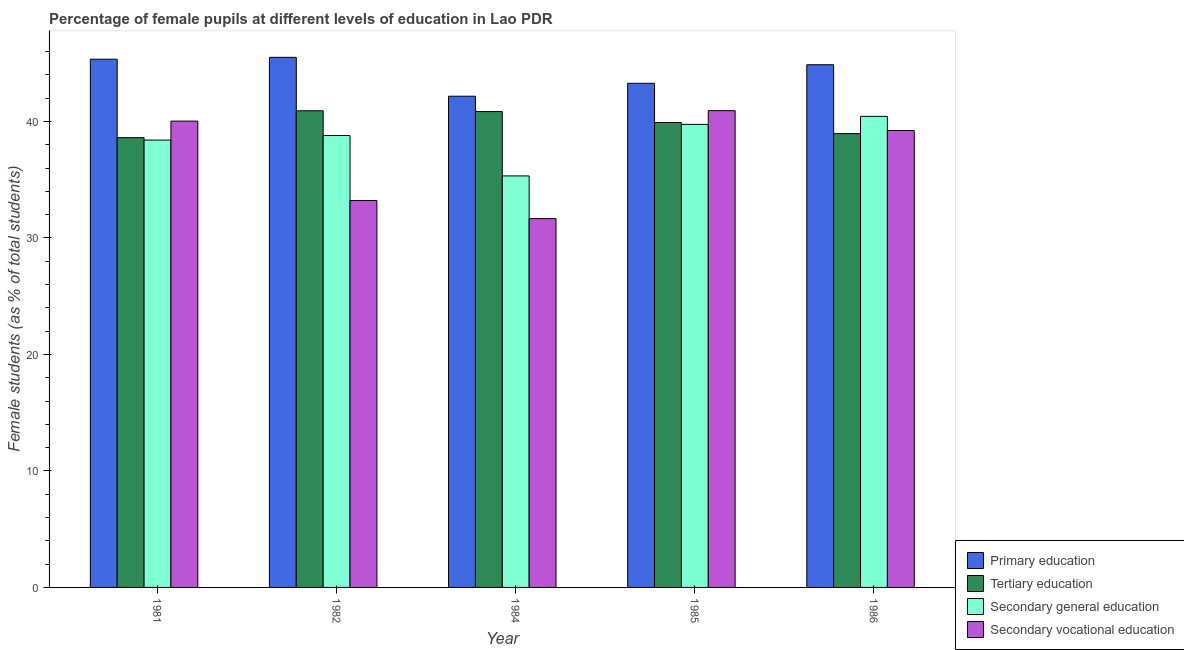How many different coloured bars are there?
Keep it short and to the point. 4. How many groups of bars are there?
Provide a short and direct response. 5. What is the label of the 4th group of bars from the left?
Your answer should be very brief. 1985. In how many cases, is the number of bars for a given year not equal to the number of legend labels?
Make the answer very short. 0. What is the percentage of female students in primary education in 1984?
Offer a very short reply. 42.16. Across all years, what is the maximum percentage of female students in primary education?
Keep it short and to the point. 45.5. Across all years, what is the minimum percentage of female students in tertiary education?
Ensure brevity in your answer.  38.61. What is the total percentage of female students in secondary vocational education in the graph?
Give a very brief answer. 185.03. What is the difference between the percentage of female students in secondary vocational education in 1984 and that in 1986?
Provide a succinct answer. -7.56. What is the difference between the percentage of female students in secondary vocational education in 1981 and the percentage of female students in secondary education in 1984?
Make the answer very short. 8.37. What is the average percentage of female students in secondary vocational education per year?
Your response must be concise. 37.01. In the year 1982, what is the difference between the percentage of female students in secondary vocational education and percentage of female students in primary education?
Your answer should be very brief. 0. What is the ratio of the percentage of female students in primary education in 1984 to that in 1986?
Provide a short and direct response. 0.94. Is the difference between the percentage of female students in tertiary education in 1982 and 1984 greater than the difference between the percentage of female students in primary education in 1982 and 1984?
Offer a very short reply. No. What is the difference between the highest and the second highest percentage of female students in secondary education?
Ensure brevity in your answer.  0.69. What is the difference between the highest and the lowest percentage of female students in secondary education?
Offer a very short reply. 5.11. In how many years, is the percentage of female students in secondary vocational education greater than the average percentage of female students in secondary vocational education taken over all years?
Give a very brief answer. 3. What does the 3rd bar from the left in 1984 represents?
Offer a terse response. Secondary general education. What does the 2nd bar from the right in 1984 represents?
Provide a succinct answer. Secondary general education. How many years are there in the graph?
Your answer should be very brief. 5. Where does the legend appear in the graph?
Your response must be concise. Bottom right. How many legend labels are there?
Offer a terse response. 4. What is the title of the graph?
Make the answer very short. Percentage of female pupils at different levels of education in Lao PDR. Does "Bird species" appear as one of the legend labels in the graph?
Your response must be concise. No. What is the label or title of the X-axis?
Your answer should be compact. Year. What is the label or title of the Y-axis?
Your answer should be compact. Female students (as % of total students). What is the Female students (as % of total students) in Primary education in 1981?
Keep it short and to the point. 45.34. What is the Female students (as % of total students) in Tertiary education in 1981?
Offer a terse response. 38.61. What is the Female students (as % of total students) in Secondary general education in 1981?
Offer a very short reply. 38.4. What is the Female students (as % of total students) in Secondary vocational education in 1981?
Provide a short and direct response. 40.03. What is the Female students (as % of total students) in Primary education in 1982?
Your response must be concise. 45.5. What is the Female students (as % of total students) in Tertiary education in 1982?
Offer a terse response. 40.91. What is the Female students (as % of total students) of Secondary general education in 1982?
Your response must be concise. 38.79. What is the Female students (as % of total students) of Secondary vocational education in 1982?
Your response must be concise. 33.21. What is the Female students (as % of total students) in Primary education in 1984?
Your answer should be very brief. 42.16. What is the Female students (as % of total students) in Tertiary education in 1984?
Provide a short and direct response. 40.84. What is the Female students (as % of total students) in Secondary general education in 1984?
Offer a very short reply. 35.32. What is the Female students (as % of total students) in Secondary vocational education in 1984?
Make the answer very short. 31.66. What is the Female students (as % of total students) in Primary education in 1985?
Ensure brevity in your answer.  43.27. What is the Female students (as % of total students) of Tertiary education in 1985?
Make the answer very short. 39.9. What is the Female students (as % of total students) of Secondary general education in 1985?
Your answer should be compact. 39.74. What is the Female students (as % of total students) of Secondary vocational education in 1985?
Make the answer very short. 40.92. What is the Female students (as % of total students) of Primary education in 1986?
Give a very brief answer. 44.86. What is the Female students (as % of total students) of Tertiary education in 1986?
Provide a succinct answer. 38.95. What is the Female students (as % of total students) in Secondary general education in 1986?
Provide a succinct answer. 40.43. What is the Female students (as % of total students) of Secondary vocational education in 1986?
Ensure brevity in your answer.  39.22. Across all years, what is the maximum Female students (as % of total students) in Primary education?
Ensure brevity in your answer.  45.5. Across all years, what is the maximum Female students (as % of total students) of Tertiary education?
Your response must be concise. 40.91. Across all years, what is the maximum Female students (as % of total students) of Secondary general education?
Provide a succinct answer. 40.43. Across all years, what is the maximum Female students (as % of total students) in Secondary vocational education?
Keep it short and to the point. 40.92. Across all years, what is the minimum Female students (as % of total students) in Primary education?
Your answer should be very brief. 42.16. Across all years, what is the minimum Female students (as % of total students) in Tertiary education?
Give a very brief answer. 38.61. Across all years, what is the minimum Female students (as % of total students) in Secondary general education?
Give a very brief answer. 35.32. Across all years, what is the minimum Female students (as % of total students) of Secondary vocational education?
Provide a succinct answer. 31.66. What is the total Female students (as % of total students) in Primary education in the graph?
Provide a succinct answer. 221.13. What is the total Female students (as % of total students) of Tertiary education in the graph?
Your answer should be compact. 199.22. What is the total Female students (as % of total students) in Secondary general education in the graph?
Offer a very short reply. 192.69. What is the total Female students (as % of total students) in Secondary vocational education in the graph?
Your response must be concise. 185.03. What is the difference between the Female students (as % of total students) in Primary education in 1981 and that in 1982?
Your answer should be compact. -0.16. What is the difference between the Female students (as % of total students) in Tertiary education in 1981 and that in 1982?
Make the answer very short. -2.31. What is the difference between the Female students (as % of total students) of Secondary general education in 1981 and that in 1982?
Provide a succinct answer. -0.39. What is the difference between the Female students (as % of total students) of Secondary vocational education in 1981 and that in 1982?
Offer a very short reply. 6.82. What is the difference between the Female students (as % of total students) in Primary education in 1981 and that in 1984?
Your answer should be compact. 3.17. What is the difference between the Female students (as % of total students) in Tertiary education in 1981 and that in 1984?
Provide a short and direct response. -2.24. What is the difference between the Female students (as % of total students) in Secondary general education in 1981 and that in 1984?
Keep it short and to the point. 3.08. What is the difference between the Female students (as % of total students) of Secondary vocational education in 1981 and that in 1984?
Make the answer very short. 8.37. What is the difference between the Female students (as % of total students) of Primary education in 1981 and that in 1985?
Your answer should be very brief. 2.07. What is the difference between the Female students (as % of total students) in Tertiary education in 1981 and that in 1985?
Offer a very short reply. -1.3. What is the difference between the Female students (as % of total students) of Secondary general education in 1981 and that in 1985?
Give a very brief answer. -1.34. What is the difference between the Female students (as % of total students) of Secondary vocational education in 1981 and that in 1985?
Offer a terse response. -0.9. What is the difference between the Female students (as % of total students) of Primary education in 1981 and that in 1986?
Ensure brevity in your answer.  0.47. What is the difference between the Female students (as % of total students) in Tertiary education in 1981 and that in 1986?
Offer a very short reply. -0.35. What is the difference between the Female students (as % of total students) in Secondary general education in 1981 and that in 1986?
Offer a terse response. -2.04. What is the difference between the Female students (as % of total students) in Secondary vocational education in 1981 and that in 1986?
Provide a succinct answer. 0.81. What is the difference between the Female students (as % of total students) of Primary education in 1982 and that in 1984?
Your answer should be compact. 3.34. What is the difference between the Female students (as % of total students) in Tertiary education in 1982 and that in 1984?
Keep it short and to the point. 0.07. What is the difference between the Female students (as % of total students) of Secondary general education in 1982 and that in 1984?
Offer a terse response. 3.47. What is the difference between the Female students (as % of total students) of Secondary vocational education in 1982 and that in 1984?
Make the answer very short. 1.55. What is the difference between the Female students (as % of total students) of Primary education in 1982 and that in 1985?
Provide a succinct answer. 2.23. What is the difference between the Female students (as % of total students) of Tertiary education in 1982 and that in 1985?
Offer a terse response. 1.01. What is the difference between the Female students (as % of total students) in Secondary general education in 1982 and that in 1985?
Your response must be concise. -0.96. What is the difference between the Female students (as % of total students) in Secondary vocational education in 1982 and that in 1985?
Offer a terse response. -7.72. What is the difference between the Female students (as % of total students) of Primary education in 1982 and that in 1986?
Your response must be concise. 0.64. What is the difference between the Female students (as % of total students) in Tertiary education in 1982 and that in 1986?
Your answer should be compact. 1.96. What is the difference between the Female students (as % of total students) in Secondary general education in 1982 and that in 1986?
Give a very brief answer. -1.65. What is the difference between the Female students (as % of total students) in Secondary vocational education in 1982 and that in 1986?
Ensure brevity in your answer.  -6.01. What is the difference between the Female students (as % of total students) of Primary education in 1984 and that in 1985?
Provide a succinct answer. -1.11. What is the difference between the Female students (as % of total students) in Tertiary education in 1984 and that in 1985?
Offer a terse response. 0.94. What is the difference between the Female students (as % of total students) of Secondary general education in 1984 and that in 1985?
Give a very brief answer. -4.42. What is the difference between the Female students (as % of total students) of Secondary vocational education in 1984 and that in 1985?
Your answer should be very brief. -9.27. What is the difference between the Female students (as % of total students) of Primary education in 1984 and that in 1986?
Provide a short and direct response. -2.7. What is the difference between the Female students (as % of total students) in Tertiary education in 1984 and that in 1986?
Your response must be concise. 1.89. What is the difference between the Female students (as % of total students) in Secondary general education in 1984 and that in 1986?
Offer a terse response. -5.11. What is the difference between the Female students (as % of total students) of Secondary vocational education in 1984 and that in 1986?
Offer a terse response. -7.56. What is the difference between the Female students (as % of total students) in Primary education in 1985 and that in 1986?
Keep it short and to the point. -1.59. What is the difference between the Female students (as % of total students) in Tertiary education in 1985 and that in 1986?
Provide a succinct answer. 0.95. What is the difference between the Female students (as % of total students) in Secondary general education in 1985 and that in 1986?
Your answer should be compact. -0.69. What is the difference between the Female students (as % of total students) of Secondary vocational education in 1985 and that in 1986?
Offer a very short reply. 1.71. What is the difference between the Female students (as % of total students) in Primary education in 1981 and the Female students (as % of total students) in Tertiary education in 1982?
Your response must be concise. 4.42. What is the difference between the Female students (as % of total students) of Primary education in 1981 and the Female students (as % of total students) of Secondary general education in 1982?
Ensure brevity in your answer.  6.55. What is the difference between the Female students (as % of total students) of Primary education in 1981 and the Female students (as % of total students) of Secondary vocational education in 1982?
Provide a succinct answer. 12.13. What is the difference between the Female students (as % of total students) in Tertiary education in 1981 and the Female students (as % of total students) in Secondary general education in 1982?
Offer a very short reply. -0.18. What is the difference between the Female students (as % of total students) of Tertiary education in 1981 and the Female students (as % of total students) of Secondary vocational education in 1982?
Provide a succinct answer. 5.4. What is the difference between the Female students (as % of total students) of Secondary general education in 1981 and the Female students (as % of total students) of Secondary vocational education in 1982?
Offer a terse response. 5.19. What is the difference between the Female students (as % of total students) in Primary education in 1981 and the Female students (as % of total students) in Tertiary education in 1984?
Your answer should be compact. 4.49. What is the difference between the Female students (as % of total students) of Primary education in 1981 and the Female students (as % of total students) of Secondary general education in 1984?
Your answer should be very brief. 10.02. What is the difference between the Female students (as % of total students) in Primary education in 1981 and the Female students (as % of total students) in Secondary vocational education in 1984?
Keep it short and to the point. 13.68. What is the difference between the Female students (as % of total students) of Tertiary education in 1981 and the Female students (as % of total students) of Secondary general education in 1984?
Make the answer very short. 3.28. What is the difference between the Female students (as % of total students) in Tertiary education in 1981 and the Female students (as % of total students) in Secondary vocational education in 1984?
Give a very brief answer. 6.95. What is the difference between the Female students (as % of total students) of Secondary general education in 1981 and the Female students (as % of total students) of Secondary vocational education in 1984?
Your response must be concise. 6.74. What is the difference between the Female students (as % of total students) of Primary education in 1981 and the Female students (as % of total students) of Tertiary education in 1985?
Provide a short and direct response. 5.43. What is the difference between the Female students (as % of total students) in Primary education in 1981 and the Female students (as % of total students) in Secondary general education in 1985?
Give a very brief answer. 5.59. What is the difference between the Female students (as % of total students) in Primary education in 1981 and the Female students (as % of total students) in Secondary vocational education in 1985?
Provide a short and direct response. 4.41. What is the difference between the Female students (as % of total students) in Tertiary education in 1981 and the Female students (as % of total students) in Secondary general education in 1985?
Offer a terse response. -1.14. What is the difference between the Female students (as % of total students) of Tertiary education in 1981 and the Female students (as % of total students) of Secondary vocational education in 1985?
Keep it short and to the point. -2.32. What is the difference between the Female students (as % of total students) in Secondary general education in 1981 and the Female students (as % of total students) in Secondary vocational education in 1985?
Offer a terse response. -2.52. What is the difference between the Female students (as % of total students) of Primary education in 1981 and the Female students (as % of total students) of Tertiary education in 1986?
Provide a short and direct response. 6.38. What is the difference between the Female students (as % of total students) of Primary education in 1981 and the Female students (as % of total students) of Secondary general education in 1986?
Give a very brief answer. 4.9. What is the difference between the Female students (as % of total students) of Primary education in 1981 and the Female students (as % of total students) of Secondary vocational education in 1986?
Offer a terse response. 6.12. What is the difference between the Female students (as % of total students) of Tertiary education in 1981 and the Female students (as % of total students) of Secondary general education in 1986?
Ensure brevity in your answer.  -1.83. What is the difference between the Female students (as % of total students) of Tertiary education in 1981 and the Female students (as % of total students) of Secondary vocational education in 1986?
Make the answer very short. -0.61. What is the difference between the Female students (as % of total students) in Secondary general education in 1981 and the Female students (as % of total students) in Secondary vocational education in 1986?
Make the answer very short. -0.82. What is the difference between the Female students (as % of total students) in Primary education in 1982 and the Female students (as % of total students) in Tertiary education in 1984?
Ensure brevity in your answer.  4.66. What is the difference between the Female students (as % of total students) of Primary education in 1982 and the Female students (as % of total students) of Secondary general education in 1984?
Offer a terse response. 10.18. What is the difference between the Female students (as % of total students) of Primary education in 1982 and the Female students (as % of total students) of Secondary vocational education in 1984?
Offer a terse response. 13.84. What is the difference between the Female students (as % of total students) of Tertiary education in 1982 and the Female students (as % of total students) of Secondary general education in 1984?
Offer a very short reply. 5.59. What is the difference between the Female students (as % of total students) in Tertiary education in 1982 and the Female students (as % of total students) in Secondary vocational education in 1984?
Your answer should be very brief. 9.26. What is the difference between the Female students (as % of total students) of Secondary general education in 1982 and the Female students (as % of total students) of Secondary vocational education in 1984?
Your answer should be compact. 7.13. What is the difference between the Female students (as % of total students) in Primary education in 1982 and the Female students (as % of total students) in Tertiary education in 1985?
Your answer should be very brief. 5.6. What is the difference between the Female students (as % of total students) of Primary education in 1982 and the Female students (as % of total students) of Secondary general education in 1985?
Provide a succinct answer. 5.76. What is the difference between the Female students (as % of total students) of Primary education in 1982 and the Female students (as % of total students) of Secondary vocational education in 1985?
Offer a terse response. 4.58. What is the difference between the Female students (as % of total students) of Tertiary education in 1982 and the Female students (as % of total students) of Secondary general education in 1985?
Provide a short and direct response. 1.17. What is the difference between the Female students (as % of total students) of Tertiary education in 1982 and the Female students (as % of total students) of Secondary vocational education in 1985?
Keep it short and to the point. -0.01. What is the difference between the Female students (as % of total students) of Secondary general education in 1982 and the Female students (as % of total students) of Secondary vocational education in 1985?
Offer a terse response. -2.14. What is the difference between the Female students (as % of total students) of Primary education in 1982 and the Female students (as % of total students) of Tertiary education in 1986?
Give a very brief answer. 6.55. What is the difference between the Female students (as % of total students) of Primary education in 1982 and the Female students (as % of total students) of Secondary general education in 1986?
Make the answer very short. 5.07. What is the difference between the Female students (as % of total students) in Primary education in 1982 and the Female students (as % of total students) in Secondary vocational education in 1986?
Offer a very short reply. 6.28. What is the difference between the Female students (as % of total students) of Tertiary education in 1982 and the Female students (as % of total students) of Secondary general education in 1986?
Offer a very short reply. 0.48. What is the difference between the Female students (as % of total students) in Tertiary education in 1982 and the Female students (as % of total students) in Secondary vocational education in 1986?
Your answer should be compact. 1.7. What is the difference between the Female students (as % of total students) of Secondary general education in 1982 and the Female students (as % of total students) of Secondary vocational education in 1986?
Your answer should be very brief. -0.43. What is the difference between the Female students (as % of total students) in Primary education in 1984 and the Female students (as % of total students) in Tertiary education in 1985?
Offer a terse response. 2.26. What is the difference between the Female students (as % of total students) of Primary education in 1984 and the Female students (as % of total students) of Secondary general education in 1985?
Make the answer very short. 2.42. What is the difference between the Female students (as % of total students) of Primary education in 1984 and the Female students (as % of total students) of Secondary vocational education in 1985?
Give a very brief answer. 1.24. What is the difference between the Female students (as % of total students) in Tertiary education in 1984 and the Female students (as % of total students) in Secondary general education in 1985?
Your answer should be compact. 1.1. What is the difference between the Female students (as % of total students) of Tertiary education in 1984 and the Female students (as % of total students) of Secondary vocational education in 1985?
Offer a very short reply. -0.08. What is the difference between the Female students (as % of total students) in Secondary general education in 1984 and the Female students (as % of total students) in Secondary vocational education in 1985?
Your answer should be compact. -5.6. What is the difference between the Female students (as % of total students) of Primary education in 1984 and the Female students (as % of total students) of Tertiary education in 1986?
Provide a short and direct response. 3.21. What is the difference between the Female students (as % of total students) of Primary education in 1984 and the Female students (as % of total students) of Secondary general education in 1986?
Provide a short and direct response. 1.73. What is the difference between the Female students (as % of total students) of Primary education in 1984 and the Female students (as % of total students) of Secondary vocational education in 1986?
Give a very brief answer. 2.95. What is the difference between the Female students (as % of total students) of Tertiary education in 1984 and the Female students (as % of total students) of Secondary general education in 1986?
Ensure brevity in your answer.  0.41. What is the difference between the Female students (as % of total students) in Tertiary education in 1984 and the Female students (as % of total students) in Secondary vocational education in 1986?
Your response must be concise. 1.63. What is the difference between the Female students (as % of total students) in Secondary general education in 1984 and the Female students (as % of total students) in Secondary vocational education in 1986?
Provide a short and direct response. -3.9. What is the difference between the Female students (as % of total students) in Primary education in 1985 and the Female students (as % of total students) in Tertiary education in 1986?
Your answer should be very brief. 4.32. What is the difference between the Female students (as % of total students) of Primary education in 1985 and the Female students (as % of total students) of Secondary general education in 1986?
Provide a succinct answer. 2.84. What is the difference between the Female students (as % of total students) in Primary education in 1985 and the Female students (as % of total students) in Secondary vocational education in 1986?
Offer a very short reply. 4.05. What is the difference between the Female students (as % of total students) in Tertiary education in 1985 and the Female students (as % of total students) in Secondary general education in 1986?
Your response must be concise. -0.53. What is the difference between the Female students (as % of total students) of Tertiary education in 1985 and the Female students (as % of total students) of Secondary vocational education in 1986?
Your answer should be compact. 0.69. What is the difference between the Female students (as % of total students) in Secondary general education in 1985 and the Female students (as % of total students) in Secondary vocational education in 1986?
Provide a short and direct response. 0.53. What is the average Female students (as % of total students) in Primary education per year?
Offer a very short reply. 44.23. What is the average Female students (as % of total students) in Tertiary education per year?
Provide a succinct answer. 39.84. What is the average Female students (as % of total students) of Secondary general education per year?
Ensure brevity in your answer.  38.54. What is the average Female students (as % of total students) in Secondary vocational education per year?
Ensure brevity in your answer.  37.01. In the year 1981, what is the difference between the Female students (as % of total students) of Primary education and Female students (as % of total students) of Tertiary education?
Provide a succinct answer. 6.73. In the year 1981, what is the difference between the Female students (as % of total students) of Primary education and Female students (as % of total students) of Secondary general education?
Your answer should be compact. 6.94. In the year 1981, what is the difference between the Female students (as % of total students) of Primary education and Female students (as % of total students) of Secondary vocational education?
Provide a short and direct response. 5.31. In the year 1981, what is the difference between the Female students (as % of total students) in Tertiary education and Female students (as % of total students) in Secondary general education?
Offer a terse response. 0.21. In the year 1981, what is the difference between the Female students (as % of total students) in Tertiary education and Female students (as % of total students) in Secondary vocational education?
Make the answer very short. -1.42. In the year 1981, what is the difference between the Female students (as % of total students) of Secondary general education and Female students (as % of total students) of Secondary vocational education?
Provide a succinct answer. -1.63. In the year 1982, what is the difference between the Female students (as % of total students) in Primary education and Female students (as % of total students) in Tertiary education?
Keep it short and to the point. 4.59. In the year 1982, what is the difference between the Female students (as % of total students) of Primary education and Female students (as % of total students) of Secondary general education?
Your answer should be very brief. 6.71. In the year 1982, what is the difference between the Female students (as % of total students) of Primary education and Female students (as % of total students) of Secondary vocational education?
Offer a terse response. 12.29. In the year 1982, what is the difference between the Female students (as % of total students) in Tertiary education and Female students (as % of total students) in Secondary general education?
Ensure brevity in your answer.  2.13. In the year 1982, what is the difference between the Female students (as % of total students) in Tertiary education and Female students (as % of total students) in Secondary vocational education?
Your answer should be very brief. 7.71. In the year 1982, what is the difference between the Female students (as % of total students) in Secondary general education and Female students (as % of total students) in Secondary vocational education?
Make the answer very short. 5.58. In the year 1984, what is the difference between the Female students (as % of total students) in Primary education and Female students (as % of total students) in Tertiary education?
Your answer should be compact. 1.32. In the year 1984, what is the difference between the Female students (as % of total students) in Primary education and Female students (as % of total students) in Secondary general education?
Provide a short and direct response. 6.84. In the year 1984, what is the difference between the Female students (as % of total students) of Primary education and Female students (as % of total students) of Secondary vocational education?
Keep it short and to the point. 10.5. In the year 1984, what is the difference between the Female students (as % of total students) in Tertiary education and Female students (as % of total students) in Secondary general education?
Offer a very short reply. 5.52. In the year 1984, what is the difference between the Female students (as % of total students) of Tertiary education and Female students (as % of total students) of Secondary vocational education?
Provide a succinct answer. 9.19. In the year 1984, what is the difference between the Female students (as % of total students) in Secondary general education and Female students (as % of total students) in Secondary vocational education?
Give a very brief answer. 3.66. In the year 1985, what is the difference between the Female students (as % of total students) in Primary education and Female students (as % of total students) in Tertiary education?
Your response must be concise. 3.37. In the year 1985, what is the difference between the Female students (as % of total students) of Primary education and Female students (as % of total students) of Secondary general education?
Offer a terse response. 3.53. In the year 1985, what is the difference between the Female students (as % of total students) in Primary education and Female students (as % of total students) in Secondary vocational education?
Your answer should be very brief. 2.35. In the year 1985, what is the difference between the Female students (as % of total students) in Tertiary education and Female students (as % of total students) in Secondary general education?
Offer a very short reply. 0.16. In the year 1985, what is the difference between the Female students (as % of total students) in Tertiary education and Female students (as % of total students) in Secondary vocational education?
Your answer should be very brief. -1.02. In the year 1985, what is the difference between the Female students (as % of total students) in Secondary general education and Female students (as % of total students) in Secondary vocational education?
Ensure brevity in your answer.  -1.18. In the year 1986, what is the difference between the Female students (as % of total students) of Primary education and Female students (as % of total students) of Tertiary education?
Make the answer very short. 5.91. In the year 1986, what is the difference between the Female students (as % of total students) of Primary education and Female students (as % of total students) of Secondary general education?
Your answer should be compact. 4.43. In the year 1986, what is the difference between the Female students (as % of total students) in Primary education and Female students (as % of total students) in Secondary vocational education?
Provide a short and direct response. 5.65. In the year 1986, what is the difference between the Female students (as % of total students) in Tertiary education and Female students (as % of total students) in Secondary general education?
Ensure brevity in your answer.  -1.48. In the year 1986, what is the difference between the Female students (as % of total students) of Tertiary education and Female students (as % of total students) of Secondary vocational education?
Provide a short and direct response. -0.26. In the year 1986, what is the difference between the Female students (as % of total students) in Secondary general education and Female students (as % of total students) in Secondary vocational education?
Keep it short and to the point. 1.22. What is the ratio of the Female students (as % of total students) in Tertiary education in 1981 to that in 1982?
Make the answer very short. 0.94. What is the ratio of the Female students (as % of total students) of Secondary vocational education in 1981 to that in 1982?
Provide a short and direct response. 1.21. What is the ratio of the Female students (as % of total students) in Primary education in 1981 to that in 1984?
Your answer should be very brief. 1.08. What is the ratio of the Female students (as % of total students) of Tertiary education in 1981 to that in 1984?
Make the answer very short. 0.95. What is the ratio of the Female students (as % of total students) of Secondary general education in 1981 to that in 1984?
Give a very brief answer. 1.09. What is the ratio of the Female students (as % of total students) of Secondary vocational education in 1981 to that in 1984?
Offer a terse response. 1.26. What is the ratio of the Female students (as % of total students) in Primary education in 1981 to that in 1985?
Offer a very short reply. 1.05. What is the ratio of the Female students (as % of total students) of Tertiary education in 1981 to that in 1985?
Keep it short and to the point. 0.97. What is the ratio of the Female students (as % of total students) of Secondary general education in 1981 to that in 1985?
Provide a short and direct response. 0.97. What is the ratio of the Female students (as % of total students) in Secondary vocational education in 1981 to that in 1985?
Offer a terse response. 0.98. What is the ratio of the Female students (as % of total students) in Primary education in 1981 to that in 1986?
Provide a short and direct response. 1.01. What is the ratio of the Female students (as % of total students) of Tertiary education in 1981 to that in 1986?
Make the answer very short. 0.99. What is the ratio of the Female students (as % of total students) of Secondary general education in 1981 to that in 1986?
Give a very brief answer. 0.95. What is the ratio of the Female students (as % of total students) in Secondary vocational education in 1981 to that in 1986?
Your response must be concise. 1.02. What is the ratio of the Female students (as % of total students) in Primary education in 1982 to that in 1984?
Keep it short and to the point. 1.08. What is the ratio of the Female students (as % of total students) in Tertiary education in 1982 to that in 1984?
Your answer should be compact. 1. What is the ratio of the Female students (as % of total students) of Secondary general education in 1982 to that in 1984?
Make the answer very short. 1.1. What is the ratio of the Female students (as % of total students) in Secondary vocational education in 1982 to that in 1984?
Offer a very short reply. 1.05. What is the ratio of the Female students (as % of total students) in Primary education in 1982 to that in 1985?
Your answer should be very brief. 1.05. What is the ratio of the Female students (as % of total students) in Tertiary education in 1982 to that in 1985?
Offer a terse response. 1.03. What is the ratio of the Female students (as % of total students) of Secondary general education in 1982 to that in 1985?
Your response must be concise. 0.98. What is the ratio of the Female students (as % of total students) of Secondary vocational education in 1982 to that in 1985?
Keep it short and to the point. 0.81. What is the ratio of the Female students (as % of total students) in Primary education in 1982 to that in 1986?
Offer a terse response. 1.01. What is the ratio of the Female students (as % of total students) of Tertiary education in 1982 to that in 1986?
Your answer should be compact. 1.05. What is the ratio of the Female students (as % of total students) of Secondary general education in 1982 to that in 1986?
Keep it short and to the point. 0.96. What is the ratio of the Female students (as % of total students) in Secondary vocational education in 1982 to that in 1986?
Your response must be concise. 0.85. What is the ratio of the Female students (as % of total students) of Primary education in 1984 to that in 1985?
Offer a very short reply. 0.97. What is the ratio of the Female students (as % of total students) of Tertiary education in 1984 to that in 1985?
Ensure brevity in your answer.  1.02. What is the ratio of the Female students (as % of total students) of Secondary general education in 1984 to that in 1985?
Ensure brevity in your answer.  0.89. What is the ratio of the Female students (as % of total students) in Secondary vocational education in 1984 to that in 1985?
Provide a succinct answer. 0.77. What is the ratio of the Female students (as % of total students) of Primary education in 1984 to that in 1986?
Offer a terse response. 0.94. What is the ratio of the Female students (as % of total students) in Tertiary education in 1984 to that in 1986?
Make the answer very short. 1.05. What is the ratio of the Female students (as % of total students) in Secondary general education in 1984 to that in 1986?
Provide a short and direct response. 0.87. What is the ratio of the Female students (as % of total students) in Secondary vocational education in 1984 to that in 1986?
Your answer should be compact. 0.81. What is the ratio of the Female students (as % of total students) in Primary education in 1985 to that in 1986?
Your response must be concise. 0.96. What is the ratio of the Female students (as % of total students) of Tertiary education in 1985 to that in 1986?
Ensure brevity in your answer.  1.02. What is the ratio of the Female students (as % of total students) in Secondary general education in 1985 to that in 1986?
Give a very brief answer. 0.98. What is the ratio of the Female students (as % of total students) of Secondary vocational education in 1985 to that in 1986?
Keep it short and to the point. 1.04. What is the difference between the highest and the second highest Female students (as % of total students) of Primary education?
Give a very brief answer. 0.16. What is the difference between the highest and the second highest Female students (as % of total students) in Tertiary education?
Your response must be concise. 0.07. What is the difference between the highest and the second highest Female students (as % of total students) of Secondary general education?
Make the answer very short. 0.69. What is the difference between the highest and the second highest Female students (as % of total students) in Secondary vocational education?
Your answer should be very brief. 0.9. What is the difference between the highest and the lowest Female students (as % of total students) of Primary education?
Provide a short and direct response. 3.34. What is the difference between the highest and the lowest Female students (as % of total students) in Tertiary education?
Provide a succinct answer. 2.31. What is the difference between the highest and the lowest Female students (as % of total students) of Secondary general education?
Keep it short and to the point. 5.11. What is the difference between the highest and the lowest Female students (as % of total students) in Secondary vocational education?
Your answer should be compact. 9.27. 